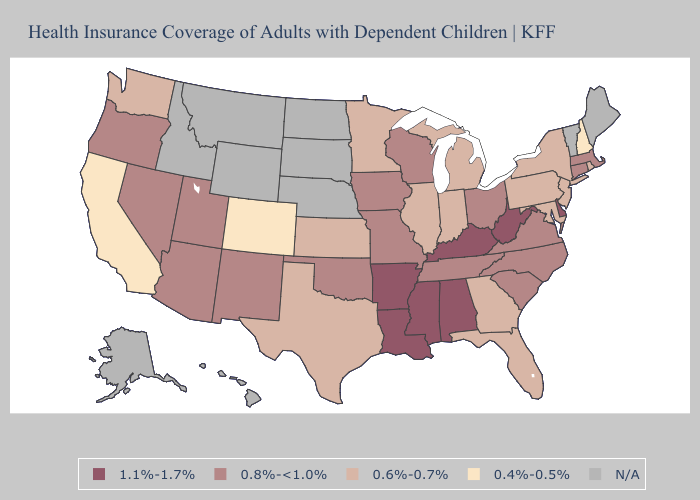Is the legend a continuous bar?
Quick response, please. No. Name the states that have a value in the range 0.8%-<1.0%?
Answer briefly. Arizona, Connecticut, Iowa, Massachusetts, Missouri, Nevada, New Mexico, North Carolina, Ohio, Oklahoma, Oregon, South Carolina, Tennessee, Utah, Virginia, Wisconsin. Which states have the lowest value in the South?
Give a very brief answer. Florida, Georgia, Maryland, Texas. Name the states that have a value in the range 0.4%-0.5%?
Be succinct. California, Colorado, New Hampshire. Name the states that have a value in the range N/A?
Keep it brief. Alaska, Hawaii, Idaho, Maine, Montana, Nebraska, North Dakota, South Dakota, Vermont, Wyoming. Name the states that have a value in the range 1.1%-1.7%?
Keep it brief. Alabama, Arkansas, Delaware, Kentucky, Louisiana, Mississippi, West Virginia. What is the value of Texas?
Be succinct. 0.6%-0.7%. What is the value of Connecticut?
Be succinct. 0.8%-<1.0%. What is the highest value in states that border Iowa?
Answer briefly. 0.8%-<1.0%. Name the states that have a value in the range N/A?
Answer briefly. Alaska, Hawaii, Idaho, Maine, Montana, Nebraska, North Dakota, South Dakota, Vermont, Wyoming. How many symbols are there in the legend?
Short answer required. 5. What is the value of Vermont?
Quick response, please. N/A. Name the states that have a value in the range 1.1%-1.7%?
Give a very brief answer. Alabama, Arkansas, Delaware, Kentucky, Louisiana, Mississippi, West Virginia. 